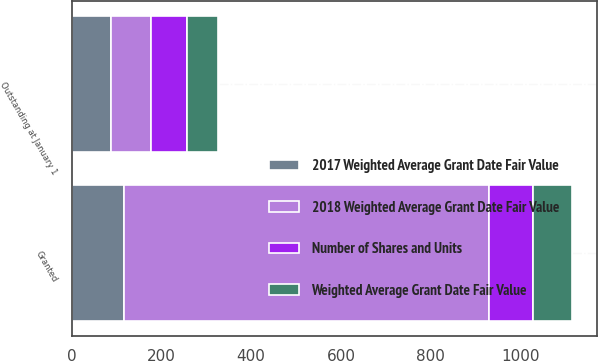Convert chart. <chart><loc_0><loc_0><loc_500><loc_500><stacked_bar_chart><ecel><fcel>Outstanding at January 1<fcel>Granted<nl><fcel>2018 Weighted Average Grant Date Fair Value<fcel>88.57<fcel>812<nl><fcel>2017 Weighted Average Grant Date Fair Value<fcel>88.57<fcel>117.55<nl><fcel>Number of Shares and Units<fcel>79.63<fcel>97.34<nl><fcel>Weighted Average Grant Date Fair Value<fcel>70.35<fcel>88.01<nl></chart> 